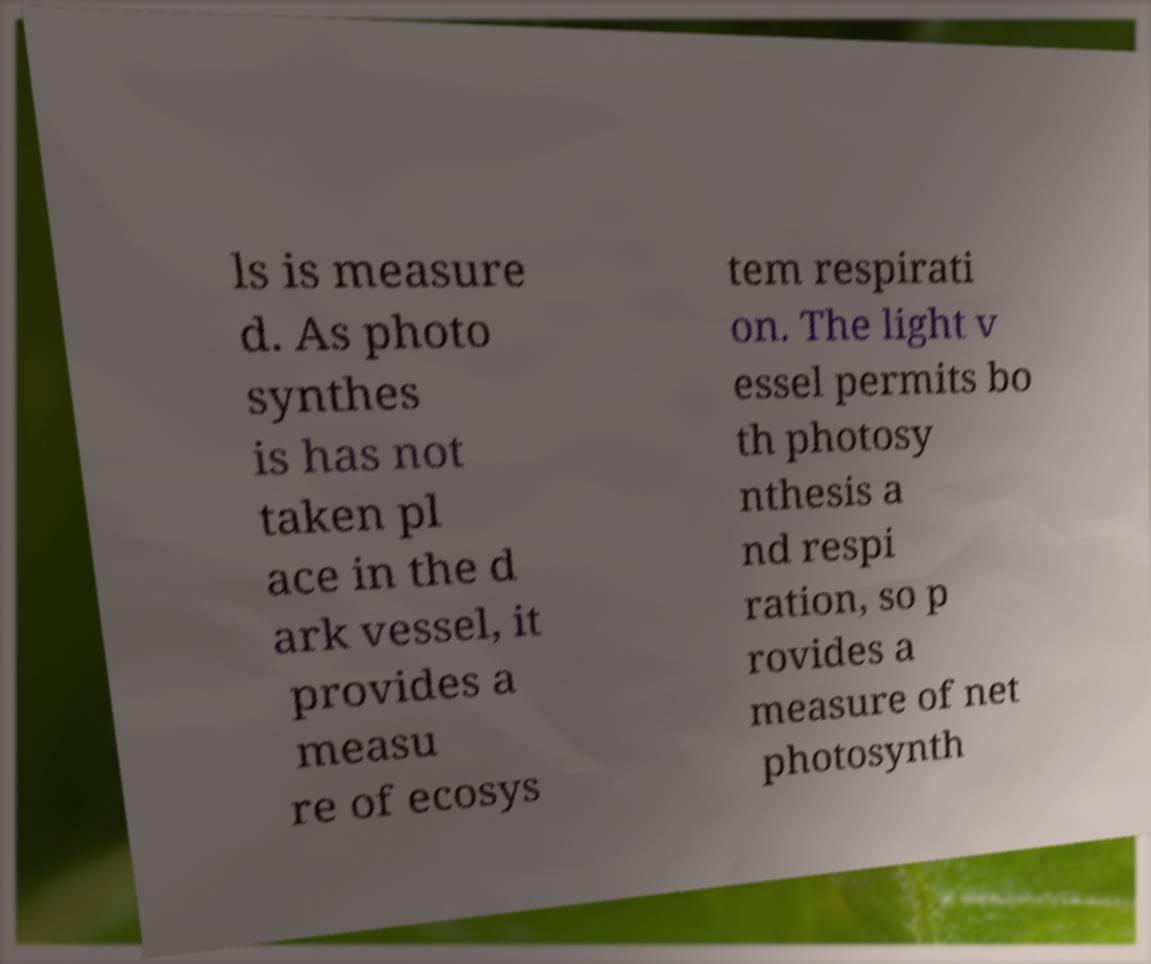Can you read and provide the text displayed in the image?This photo seems to have some interesting text. Can you extract and type it out for me? ls is measure d. As photo synthes is has not taken pl ace in the d ark vessel, it provides a measu re of ecosys tem respirati on. The light v essel permits bo th photosy nthesis a nd respi ration, so p rovides a measure of net photosynth 